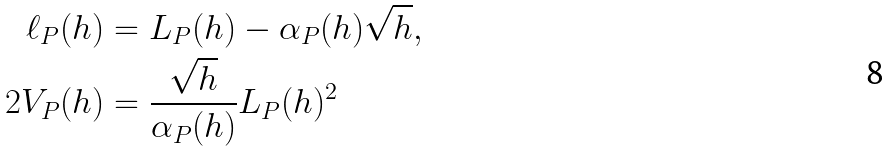<formula> <loc_0><loc_0><loc_500><loc_500>\ell _ { P } ( h ) & = L _ { P } ( h ) - \alpha _ { P } ( h ) \sqrt { h } , \\ 2 V _ { P } ( h ) & = \frac { \sqrt { h } } { \alpha _ { P } ( h ) } L _ { P } ( h ) ^ { 2 }</formula> 